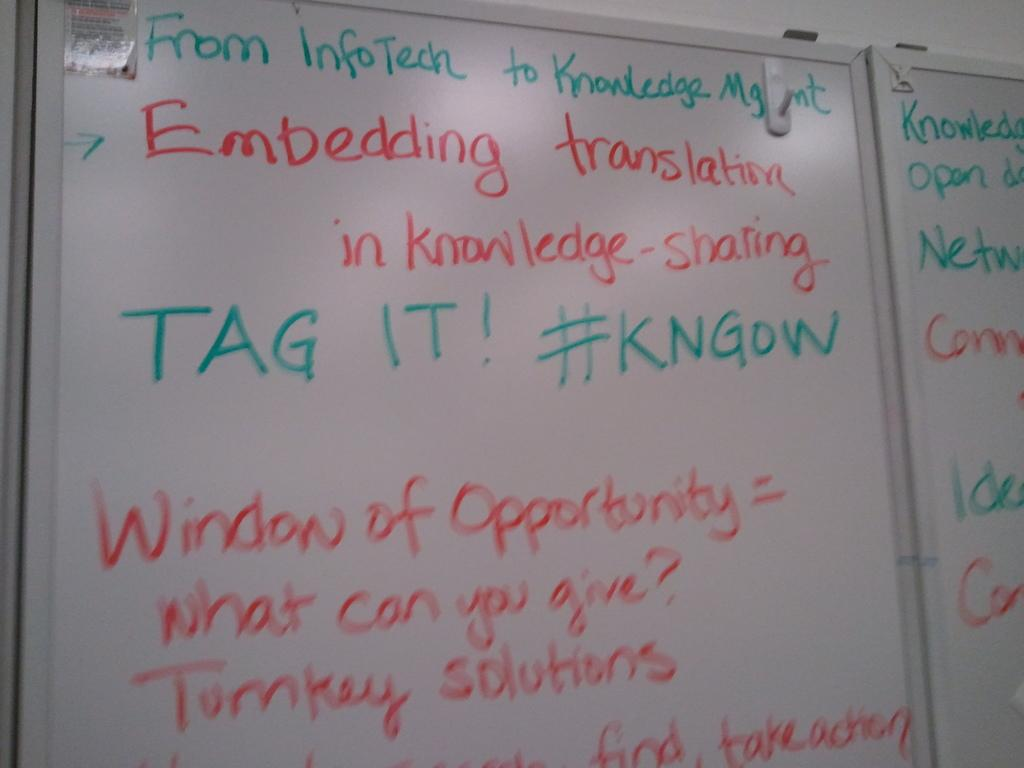<image>
Give a short and clear explanation of the subsequent image. A white board written in red and green markers stating From InfoTech to Knowledge Mgmt. 